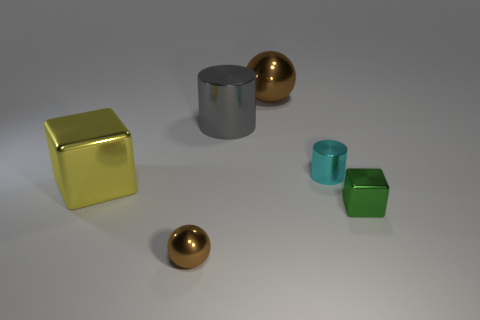Add 3 small green blocks. How many objects exist? 9 Subtract all balls. How many objects are left? 4 Add 5 tiny purple rubber things. How many tiny purple rubber things exist? 5 Subtract 0 cyan spheres. How many objects are left? 6 Subtract all tiny brown metallic objects. Subtract all big cyan metal cylinders. How many objects are left? 5 Add 1 small things. How many small things are left? 4 